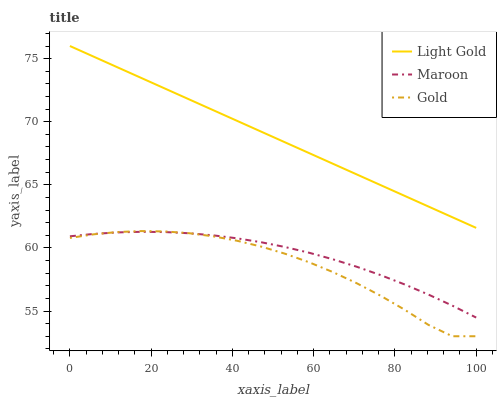Does Gold have the minimum area under the curve?
Answer yes or no. Yes. Does Light Gold have the maximum area under the curve?
Answer yes or no. Yes. Does Maroon have the minimum area under the curve?
Answer yes or no. No. Does Maroon have the maximum area under the curve?
Answer yes or no. No. Is Light Gold the smoothest?
Answer yes or no. Yes. Is Gold the roughest?
Answer yes or no. Yes. Is Maroon the smoothest?
Answer yes or no. No. Is Maroon the roughest?
Answer yes or no. No. Does Maroon have the lowest value?
Answer yes or no. No. Does Light Gold have the highest value?
Answer yes or no. Yes. Does Gold have the highest value?
Answer yes or no. No. Is Maroon less than Light Gold?
Answer yes or no. Yes. Is Light Gold greater than Gold?
Answer yes or no. Yes. Does Maroon intersect Gold?
Answer yes or no. Yes. Is Maroon less than Gold?
Answer yes or no. No. Is Maroon greater than Gold?
Answer yes or no. No. Does Maroon intersect Light Gold?
Answer yes or no. No. 